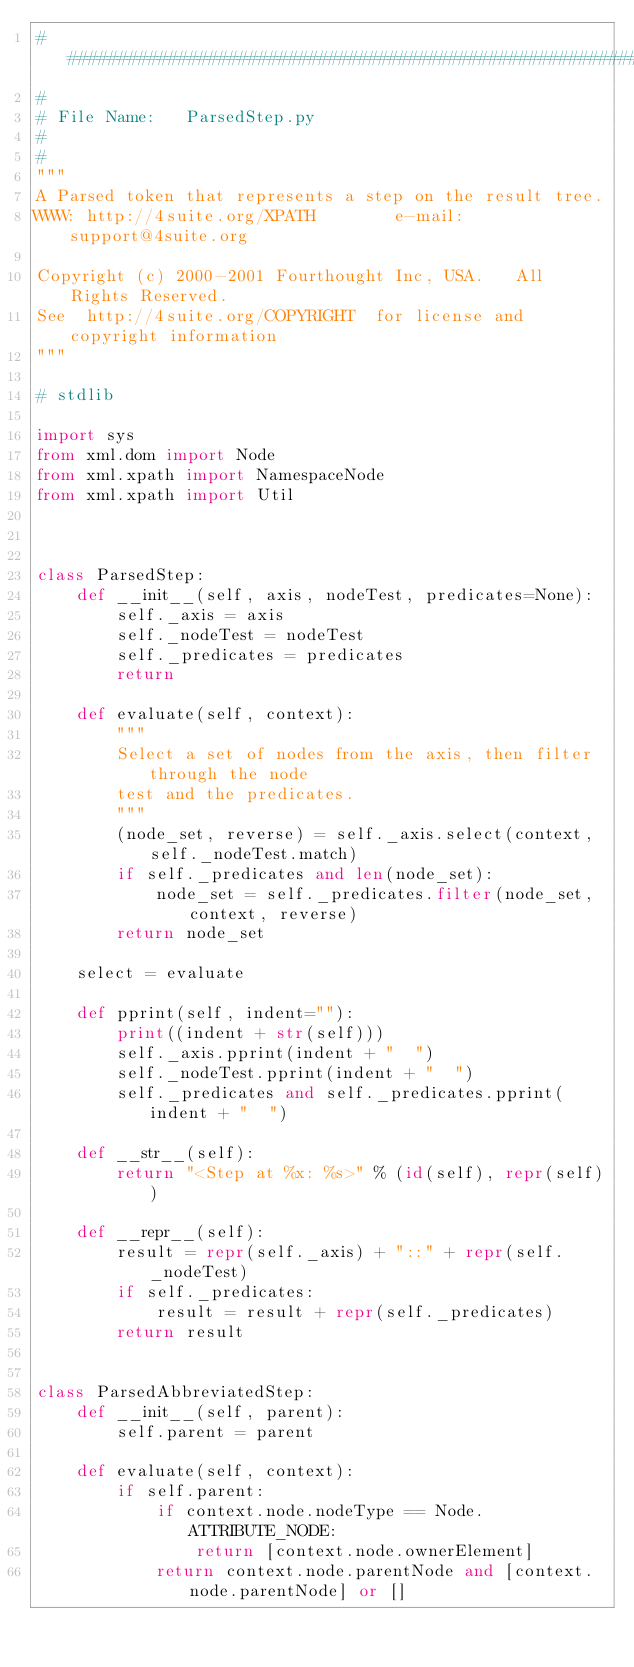<code> <loc_0><loc_0><loc_500><loc_500><_Python_>########################################################################
#
# File Name:   ParsedStep.py
#
#
"""
A Parsed token that represents a step on the result tree.
WWW: http://4suite.org/XPATH        e-mail: support@4suite.org

Copyright (c) 2000-2001 Fourthought Inc, USA.   All Rights Reserved.
See  http://4suite.org/COPYRIGHT  for license and copyright information
"""

# stdlib

import sys
from xml.dom import Node
from xml.xpath import NamespaceNode
from xml.xpath import Util



class ParsedStep:
    def __init__(self, axis, nodeTest, predicates=None):
        self._axis = axis
        self._nodeTest = nodeTest
        self._predicates = predicates
        return

    def evaluate(self, context):
        """
        Select a set of nodes from the axis, then filter through the node
        test and the predicates.
        """
        (node_set, reverse) = self._axis.select(context, self._nodeTest.match)
        if self._predicates and len(node_set):
            node_set = self._predicates.filter(node_set, context, reverse)
        return node_set

    select = evaluate

    def pprint(self, indent=""):
        print((indent + str(self)))
        self._axis.pprint(indent + "  ")
        self._nodeTest.pprint(indent + "  ")
        self._predicates and self._predicates.pprint(indent + "  ")

    def __str__(self):
        return "<Step at %x: %s>" % (id(self), repr(self))

    def __repr__(self):
        result = repr(self._axis) + "::" + repr(self._nodeTest)
        if self._predicates:
            result = result + repr(self._predicates)
        return result


class ParsedAbbreviatedStep:
    def __init__(self, parent):
        self.parent = parent

    def evaluate(self, context):
        if self.parent:
            if context.node.nodeType == Node.ATTRIBUTE_NODE:
                return [context.node.ownerElement]
            return context.node.parentNode and [context.node.parentNode] or []</code> 